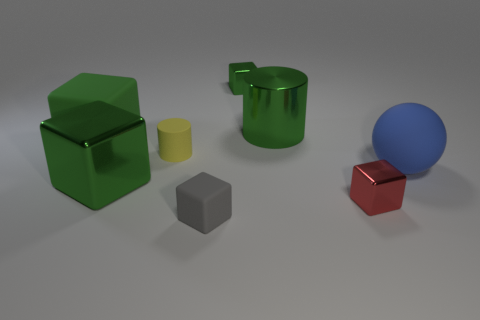There is a big metallic object in front of the small cylinder; is there a small matte object that is behind it?
Keep it short and to the point. Yes. Is the number of tiny red things behind the small gray thing less than the number of big rubber things that are to the left of the blue ball?
Provide a short and direct response. No. Is the green block that is to the right of the small matte cube made of the same material as the big blue sphere right of the small rubber cylinder?
Ensure brevity in your answer.  No. What number of large objects are metallic cubes or gray matte things?
Your answer should be compact. 1. There is a small red object that is made of the same material as the small green block; what shape is it?
Your response must be concise. Cube. Are there fewer large cubes that are to the left of the big shiny block than metal blocks?
Your answer should be very brief. Yes. Is the shape of the tiny gray thing the same as the green matte object?
Provide a short and direct response. Yes. How many rubber objects are either large green cylinders or large purple balls?
Provide a short and direct response. 0. Are there any green objects of the same size as the metallic cylinder?
Your answer should be very brief. Yes. There is a matte thing that is the same color as the metallic cylinder; what shape is it?
Your answer should be compact. Cube. 